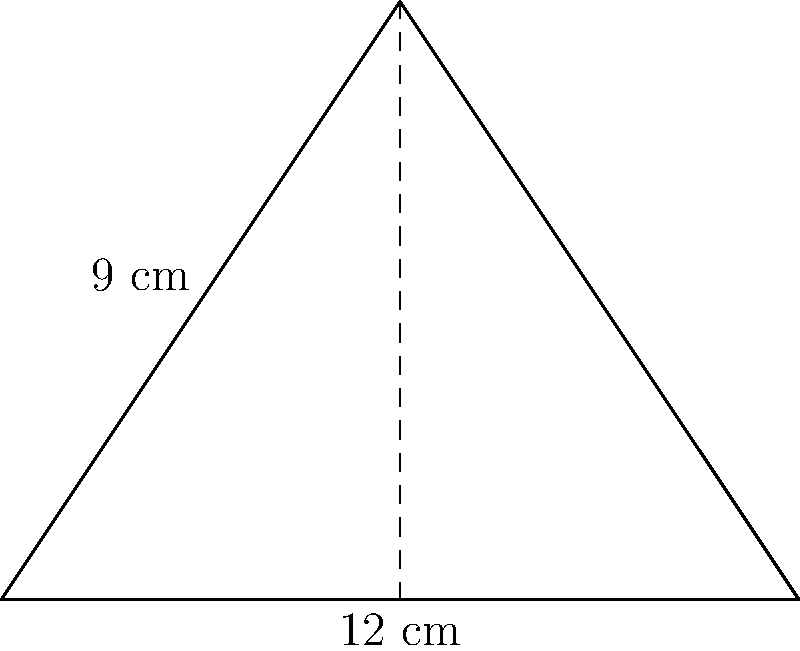As a local guide in Madrid, you're explaining the unique shape of a traditional tapas serving plate to tourists. The plate is triangular, resembling the shape shown. If the base of the plate is 12 cm and its height is 9 cm, what is the area of this tapas plate in square centimeters? To find the area of a triangular plate, we can use the formula for the area of a triangle:

$$A = \frac{1}{2} \times b \times h$$

Where:
$A$ = Area
$b$ = Base length
$h$ = Height

Given:
Base ($b$) = 12 cm
Height ($h$) = 9 cm

Let's substitute these values into the formula:

$$A = \frac{1}{2} \times 12 \text{ cm} \times 9 \text{ cm}$$

Now, let's calculate:

$$A = \frac{1}{2} \times 108 \text{ cm}^2 = 54 \text{ cm}^2$$

Therefore, the area of the triangular tapas serving plate is 54 square centimeters.
Answer: 54 cm² 